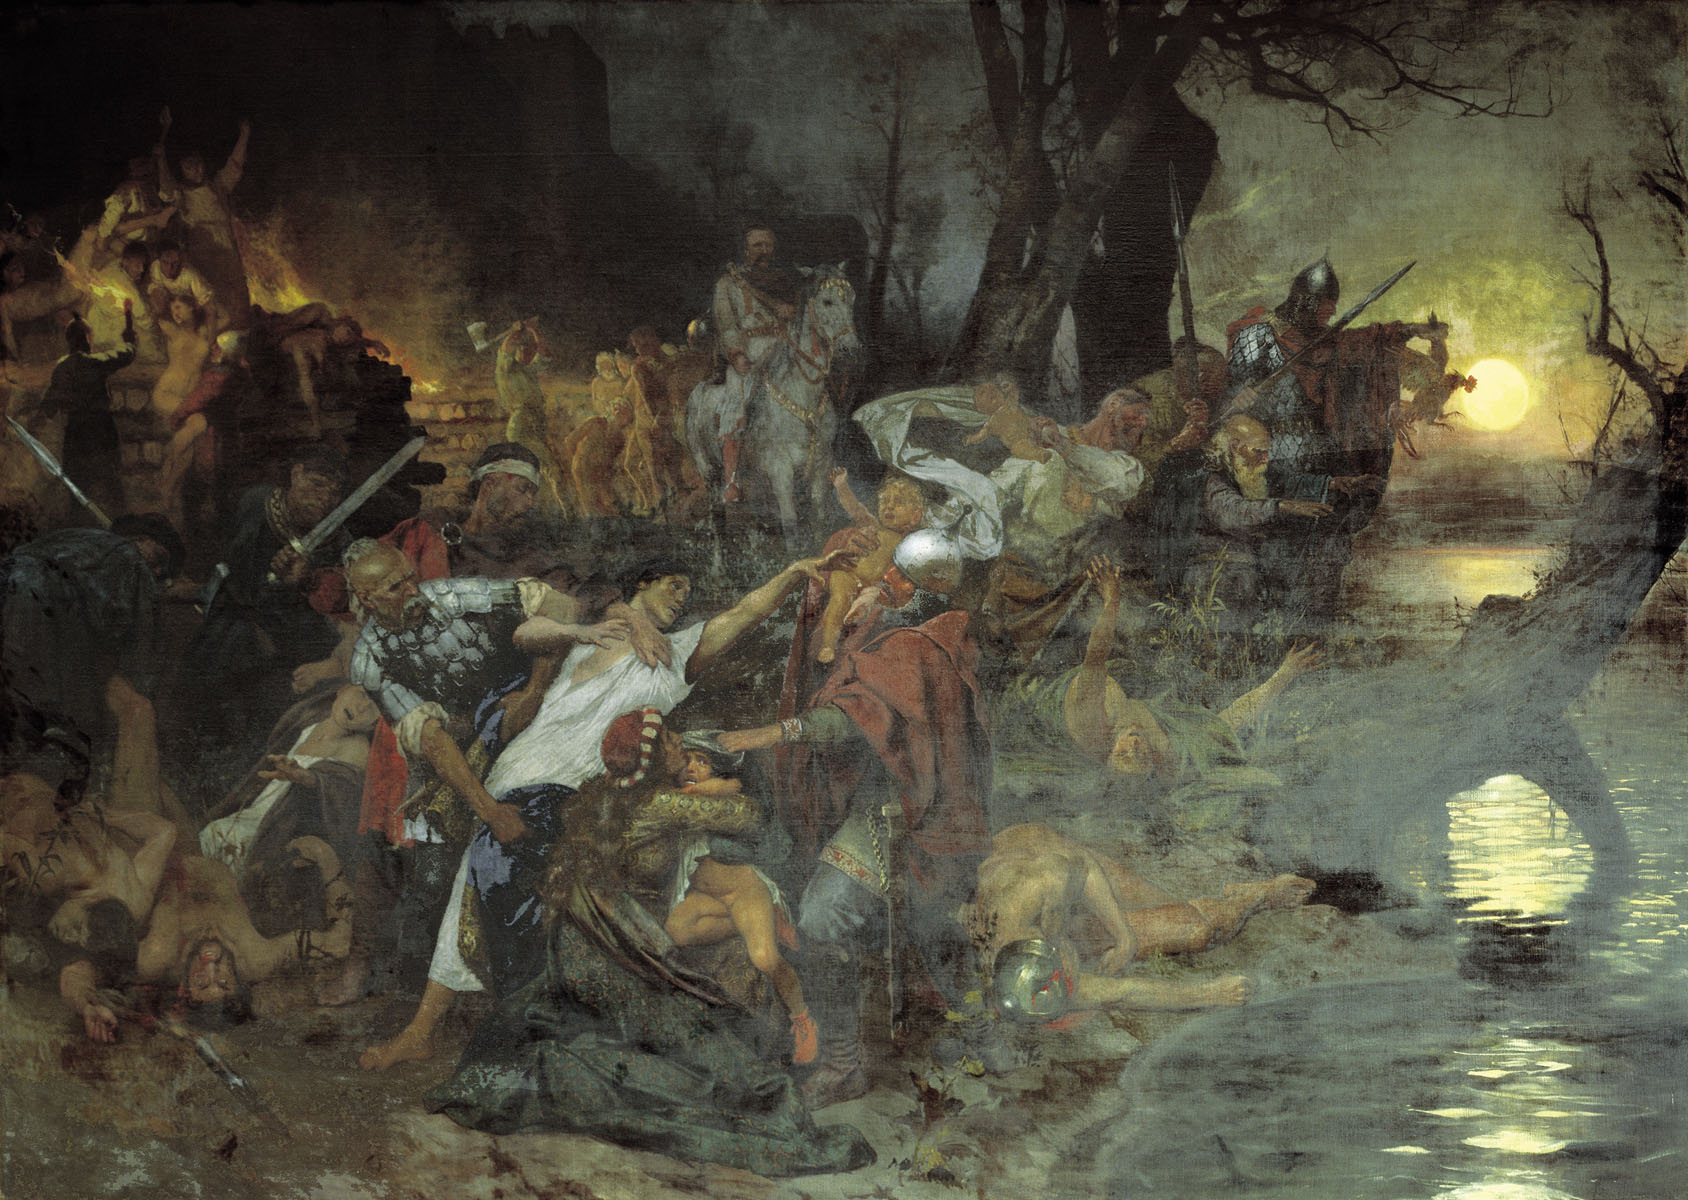What might be the historical or cultural context of this battle scene? While the specific historical context is not detailed, the style and elements suggest a medieval or possibly early Renaissance period. The weaponry, armor style, and nature of hand-to-hand combat imply a setting rooted in a time of feudal wars or large-scale national conflicts possibly within Europe. This painting might be inspired by real historical events, or it could be an imaginative depiction designed to evoke the universal themes of struggle, power, and human resilience in the face of adversity. 